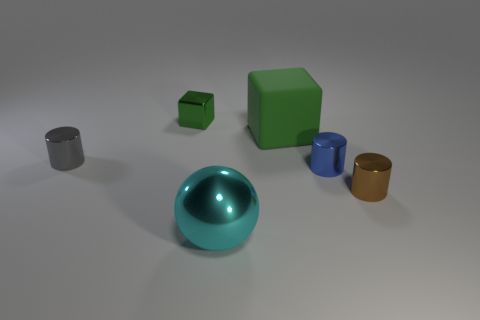Subtract all small brown cylinders. How many cylinders are left? 2 Add 1 large yellow objects. How many objects exist? 7 Subtract all purple cylinders. Subtract all red blocks. How many cylinders are left? 3 Subtract all spheres. How many objects are left? 5 Subtract all large cyan shiny blocks. Subtract all green rubber cubes. How many objects are left? 5 Add 4 small gray objects. How many small gray objects are left? 5 Add 1 large green objects. How many large green objects exist? 2 Subtract 0 brown spheres. How many objects are left? 6 